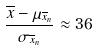<formula> <loc_0><loc_0><loc_500><loc_500>\frac { \overline { x } - \mu _ { \overline { x } _ { n } } } { \sigma _ { \overline { x } _ { n } } } \approx 3 6</formula> 